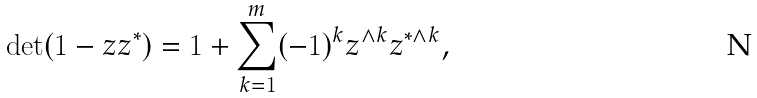<formula> <loc_0><loc_0><loc_500><loc_500>\det ( 1 - z z ^ { * } ) = 1 + \sum _ { k = 1 } ^ { m } ( - 1 ) ^ { k } z ^ { \wedge k } z ^ { * \wedge k } ,</formula> 